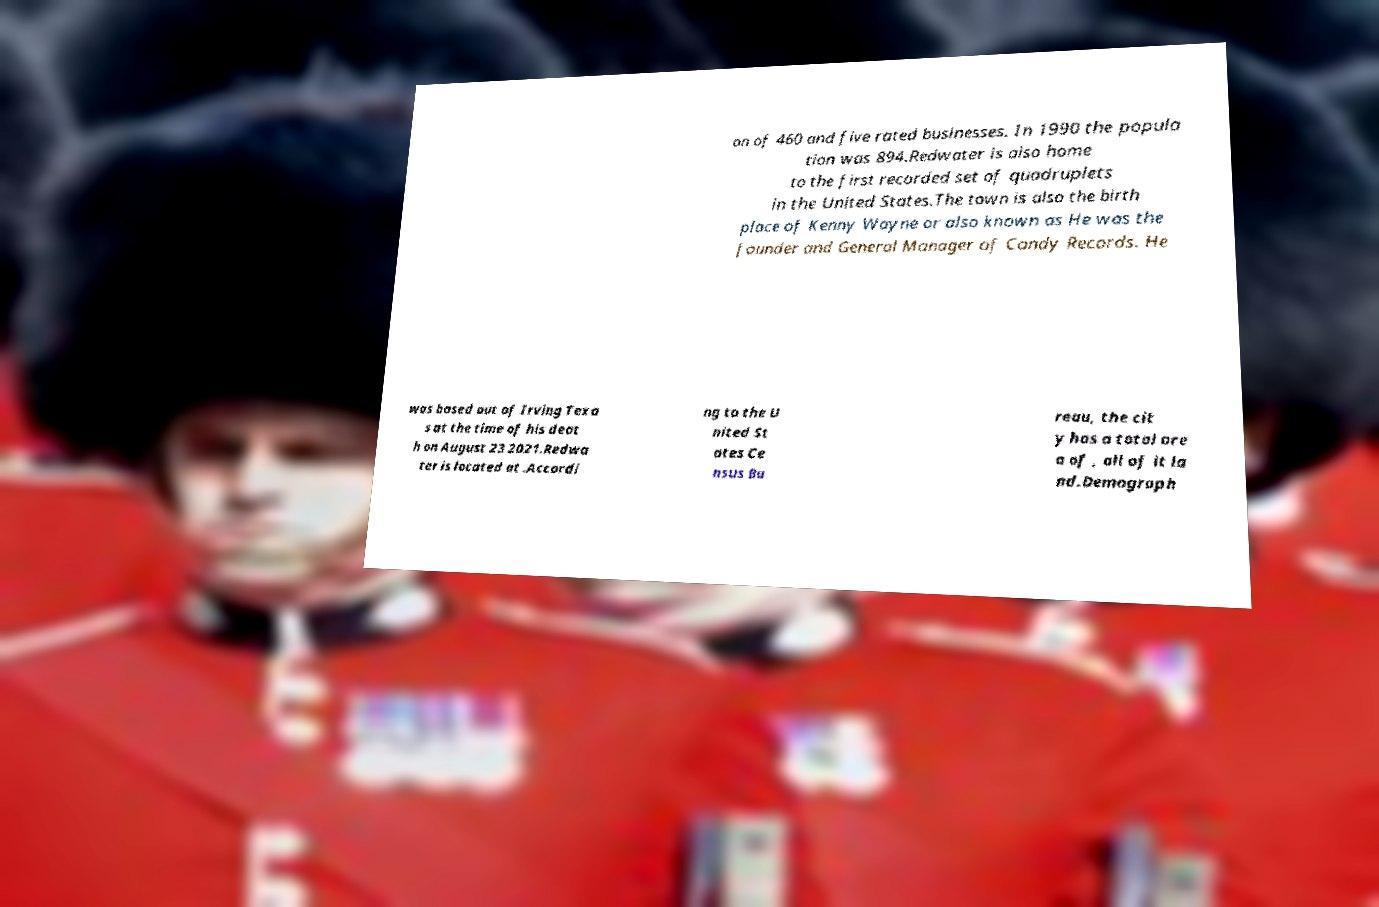What messages or text are displayed in this image? I need them in a readable, typed format. on of 460 and five rated businesses. In 1990 the popula tion was 894.Redwater is also home to the first recorded set of quadruplets in the United States.The town is also the birth place of Kenny Wayne or also known as He was the founder and General Manager of Candy Records. He was based out of Irving Texa s at the time of his deat h on August 23 2021.Redwa ter is located at .Accordi ng to the U nited St ates Ce nsus Bu reau, the cit y has a total are a of , all of it la nd.Demograph 